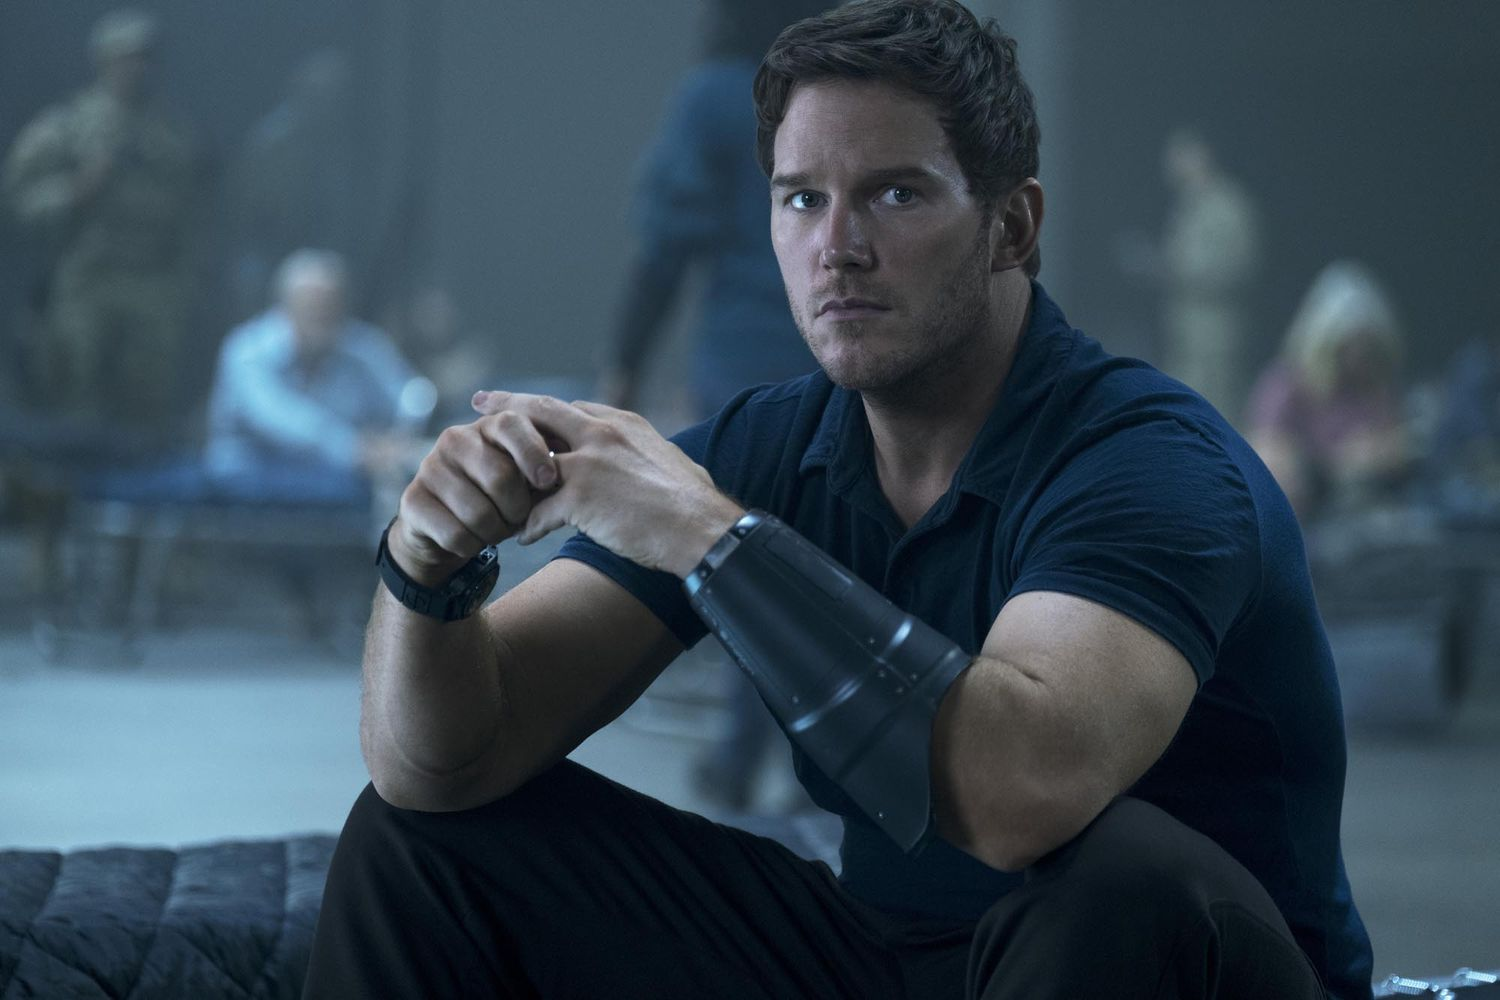Imagine this scene is from a sci-fi movie. What could the plot be about? In a sci-fi movie setting, this scene might depict a moment during an intergalactic conflict. The character could be a seasoned soldier or leader who is entrusted with a crucial task, perhaps to disarm an alien threat or recover pivotal technology. The device he's holding could be a high-tech gadget essential for the mission's success, and the blurred figures in the background are his comrades preparing for a final push or defense. What emotions might the character be feeling? The character might be feeling a mix of determination, focus, and anxiety. The serious expression suggests a readiness to act, while the intense look in his eyes may indicate the heavy responsibility he carries. What could be the objective of this mission? The objective of the mission might be to neutralize a threat, rescue individuals, or secure important information. Given the serious tone and military presence, it's likely a high-stakes operation where failure is not an option. 